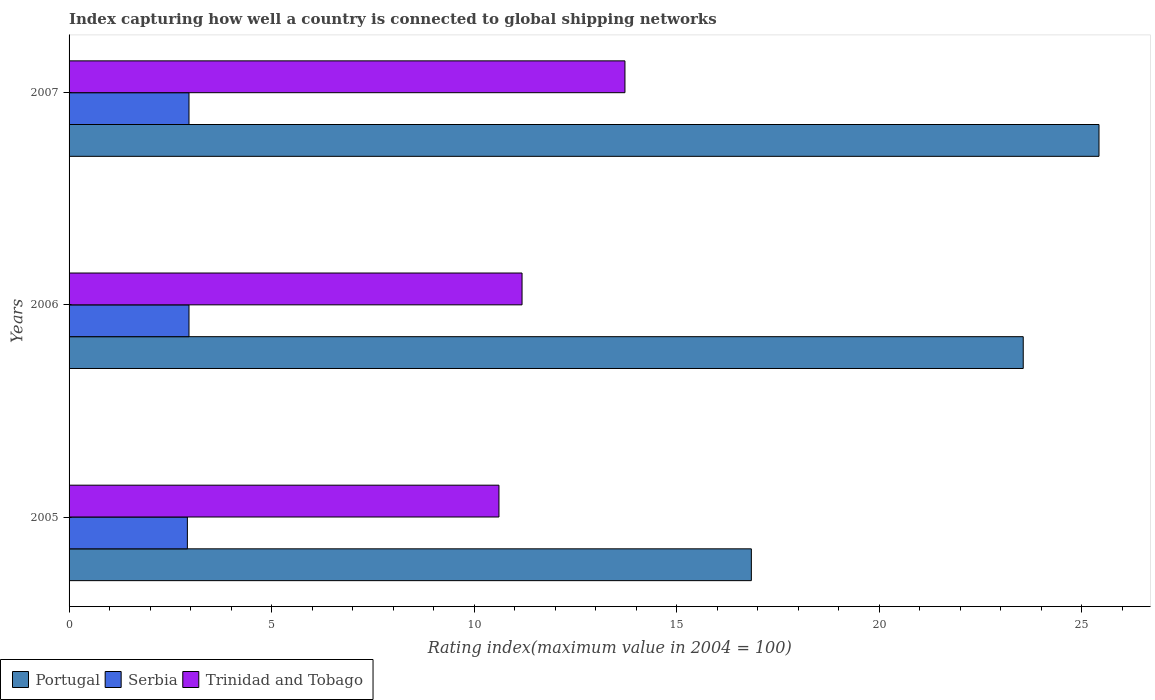How many different coloured bars are there?
Provide a succinct answer. 3. How many groups of bars are there?
Your response must be concise. 3. How many bars are there on the 1st tick from the top?
Provide a short and direct response. 3. How many bars are there on the 2nd tick from the bottom?
Offer a very short reply. 3. In how many cases, is the number of bars for a given year not equal to the number of legend labels?
Offer a very short reply. 0. What is the rating index in Trinidad and Tobago in 2007?
Your response must be concise. 13.72. Across all years, what is the maximum rating index in Serbia?
Your response must be concise. 2.96. Across all years, what is the minimum rating index in Trinidad and Tobago?
Make the answer very short. 10.61. In which year was the rating index in Trinidad and Tobago maximum?
Provide a succinct answer. 2007. What is the total rating index in Portugal in the graph?
Your answer should be very brief. 65.81. What is the difference between the rating index in Portugal in 2005 and that in 2007?
Make the answer very short. -8.58. What is the difference between the rating index in Serbia in 2005 and the rating index in Portugal in 2007?
Ensure brevity in your answer.  -22.5. What is the average rating index in Serbia per year?
Offer a very short reply. 2.95. In the year 2007, what is the difference between the rating index in Serbia and rating index in Portugal?
Give a very brief answer. -22.46. In how many years, is the rating index in Serbia greater than 5 ?
Offer a very short reply. 0. What is the ratio of the rating index in Serbia in 2005 to that in 2006?
Provide a succinct answer. 0.99. What is the difference between the highest and the second highest rating index in Trinidad and Tobago?
Your answer should be compact. 2.54. What is the difference between the highest and the lowest rating index in Serbia?
Offer a very short reply. 0.04. Is the sum of the rating index in Trinidad and Tobago in 2006 and 2007 greater than the maximum rating index in Portugal across all years?
Ensure brevity in your answer.  No. What does the 1st bar from the top in 2007 represents?
Make the answer very short. Trinidad and Tobago. What does the 1st bar from the bottom in 2007 represents?
Provide a short and direct response. Portugal. How many bars are there?
Provide a short and direct response. 9. Are all the bars in the graph horizontal?
Ensure brevity in your answer.  Yes. How many years are there in the graph?
Ensure brevity in your answer.  3. What is the difference between two consecutive major ticks on the X-axis?
Make the answer very short. 5. Are the values on the major ticks of X-axis written in scientific E-notation?
Provide a succinct answer. No. Does the graph contain any zero values?
Your answer should be compact. No. How are the legend labels stacked?
Provide a short and direct response. Horizontal. What is the title of the graph?
Your answer should be very brief. Index capturing how well a country is connected to global shipping networks. What is the label or title of the X-axis?
Provide a succinct answer. Rating index(maximum value in 2004 = 100). What is the label or title of the Y-axis?
Give a very brief answer. Years. What is the Rating index(maximum value in 2004 = 100) of Portugal in 2005?
Provide a succinct answer. 16.84. What is the Rating index(maximum value in 2004 = 100) in Serbia in 2005?
Your response must be concise. 2.92. What is the Rating index(maximum value in 2004 = 100) of Trinidad and Tobago in 2005?
Provide a short and direct response. 10.61. What is the Rating index(maximum value in 2004 = 100) of Portugal in 2006?
Make the answer very short. 23.55. What is the Rating index(maximum value in 2004 = 100) of Serbia in 2006?
Offer a terse response. 2.96. What is the Rating index(maximum value in 2004 = 100) of Trinidad and Tobago in 2006?
Offer a terse response. 11.18. What is the Rating index(maximum value in 2004 = 100) of Portugal in 2007?
Your answer should be very brief. 25.42. What is the Rating index(maximum value in 2004 = 100) in Serbia in 2007?
Keep it short and to the point. 2.96. What is the Rating index(maximum value in 2004 = 100) of Trinidad and Tobago in 2007?
Provide a short and direct response. 13.72. Across all years, what is the maximum Rating index(maximum value in 2004 = 100) of Portugal?
Provide a short and direct response. 25.42. Across all years, what is the maximum Rating index(maximum value in 2004 = 100) of Serbia?
Provide a short and direct response. 2.96. Across all years, what is the maximum Rating index(maximum value in 2004 = 100) of Trinidad and Tobago?
Ensure brevity in your answer.  13.72. Across all years, what is the minimum Rating index(maximum value in 2004 = 100) of Portugal?
Give a very brief answer. 16.84. Across all years, what is the minimum Rating index(maximum value in 2004 = 100) in Serbia?
Give a very brief answer. 2.92. Across all years, what is the minimum Rating index(maximum value in 2004 = 100) of Trinidad and Tobago?
Offer a terse response. 10.61. What is the total Rating index(maximum value in 2004 = 100) in Portugal in the graph?
Offer a very short reply. 65.81. What is the total Rating index(maximum value in 2004 = 100) of Serbia in the graph?
Make the answer very short. 8.84. What is the total Rating index(maximum value in 2004 = 100) of Trinidad and Tobago in the graph?
Offer a very short reply. 35.51. What is the difference between the Rating index(maximum value in 2004 = 100) in Portugal in 2005 and that in 2006?
Your answer should be very brief. -6.71. What is the difference between the Rating index(maximum value in 2004 = 100) in Serbia in 2005 and that in 2006?
Ensure brevity in your answer.  -0.04. What is the difference between the Rating index(maximum value in 2004 = 100) in Trinidad and Tobago in 2005 and that in 2006?
Keep it short and to the point. -0.57. What is the difference between the Rating index(maximum value in 2004 = 100) in Portugal in 2005 and that in 2007?
Keep it short and to the point. -8.58. What is the difference between the Rating index(maximum value in 2004 = 100) in Serbia in 2005 and that in 2007?
Your answer should be compact. -0.04. What is the difference between the Rating index(maximum value in 2004 = 100) in Trinidad and Tobago in 2005 and that in 2007?
Offer a very short reply. -3.11. What is the difference between the Rating index(maximum value in 2004 = 100) of Portugal in 2006 and that in 2007?
Provide a short and direct response. -1.87. What is the difference between the Rating index(maximum value in 2004 = 100) in Serbia in 2006 and that in 2007?
Your answer should be compact. 0. What is the difference between the Rating index(maximum value in 2004 = 100) in Trinidad and Tobago in 2006 and that in 2007?
Offer a terse response. -2.54. What is the difference between the Rating index(maximum value in 2004 = 100) in Portugal in 2005 and the Rating index(maximum value in 2004 = 100) in Serbia in 2006?
Your answer should be compact. 13.88. What is the difference between the Rating index(maximum value in 2004 = 100) of Portugal in 2005 and the Rating index(maximum value in 2004 = 100) of Trinidad and Tobago in 2006?
Give a very brief answer. 5.66. What is the difference between the Rating index(maximum value in 2004 = 100) in Serbia in 2005 and the Rating index(maximum value in 2004 = 100) in Trinidad and Tobago in 2006?
Offer a terse response. -8.26. What is the difference between the Rating index(maximum value in 2004 = 100) of Portugal in 2005 and the Rating index(maximum value in 2004 = 100) of Serbia in 2007?
Your answer should be compact. 13.88. What is the difference between the Rating index(maximum value in 2004 = 100) in Portugal in 2005 and the Rating index(maximum value in 2004 = 100) in Trinidad and Tobago in 2007?
Offer a very short reply. 3.12. What is the difference between the Rating index(maximum value in 2004 = 100) of Portugal in 2006 and the Rating index(maximum value in 2004 = 100) of Serbia in 2007?
Make the answer very short. 20.59. What is the difference between the Rating index(maximum value in 2004 = 100) in Portugal in 2006 and the Rating index(maximum value in 2004 = 100) in Trinidad and Tobago in 2007?
Offer a terse response. 9.83. What is the difference between the Rating index(maximum value in 2004 = 100) of Serbia in 2006 and the Rating index(maximum value in 2004 = 100) of Trinidad and Tobago in 2007?
Ensure brevity in your answer.  -10.76. What is the average Rating index(maximum value in 2004 = 100) in Portugal per year?
Provide a succinct answer. 21.94. What is the average Rating index(maximum value in 2004 = 100) of Serbia per year?
Give a very brief answer. 2.95. What is the average Rating index(maximum value in 2004 = 100) of Trinidad and Tobago per year?
Make the answer very short. 11.84. In the year 2005, what is the difference between the Rating index(maximum value in 2004 = 100) of Portugal and Rating index(maximum value in 2004 = 100) of Serbia?
Your answer should be very brief. 13.92. In the year 2005, what is the difference between the Rating index(maximum value in 2004 = 100) in Portugal and Rating index(maximum value in 2004 = 100) in Trinidad and Tobago?
Give a very brief answer. 6.23. In the year 2005, what is the difference between the Rating index(maximum value in 2004 = 100) of Serbia and Rating index(maximum value in 2004 = 100) of Trinidad and Tobago?
Offer a terse response. -7.69. In the year 2006, what is the difference between the Rating index(maximum value in 2004 = 100) in Portugal and Rating index(maximum value in 2004 = 100) in Serbia?
Offer a very short reply. 20.59. In the year 2006, what is the difference between the Rating index(maximum value in 2004 = 100) in Portugal and Rating index(maximum value in 2004 = 100) in Trinidad and Tobago?
Keep it short and to the point. 12.37. In the year 2006, what is the difference between the Rating index(maximum value in 2004 = 100) of Serbia and Rating index(maximum value in 2004 = 100) of Trinidad and Tobago?
Your response must be concise. -8.22. In the year 2007, what is the difference between the Rating index(maximum value in 2004 = 100) in Portugal and Rating index(maximum value in 2004 = 100) in Serbia?
Provide a short and direct response. 22.46. In the year 2007, what is the difference between the Rating index(maximum value in 2004 = 100) of Portugal and Rating index(maximum value in 2004 = 100) of Trinidad and Tobago?
Provide a short and direct response. 11.7. In the year 2007, what is the difference between the Rating index(maximum value in 2004 = 100) in Serbia and Rating index(maximum value in 2004 = 100) in Trinidad and Tobago?
Your answer should be compact. -10.76. What is the ratio of the Rating index(maximum value in 2004 = 100) of Portugal in 2005 to that in 2006?
Offer a very short reply. 0.72. What is the ratio of the Rating index(maximum value in 2004 = 100) in Serbia in 2005 to that in 2006?
Keep it short and to the point. 0.99. What is the ratio of the Rating index(maximum value in 2004 = 100) in Trinidad and Tobago in 2005 to that in 2006?
Offer a terse response. 0.95. What is the ratio of the Rating index(maximum value in 2004 = 100) of Portugal in 2005 to that in 2007?
Make the answer very short. 0.66. What is the ratio of the Rating index(maximum value in 2004 = 100) of Serbia in 2005 to that in 2007?
Ensure brevity in your answer.  0.99. What is the ratio of the Rating index(maximum value in 2004 = 100) of Trinidad and Tobago in 2005 to that in 2007?
Your answer should be compact. 0.77. What is the ratio of the Rating index(maximum value in 2004 = 100) in Portugal in 2006 to that in 2007?
Your answer should be very brief. 0.93. What is the ratio of the Rating index(maximum value in 2004 = 100) of Serbia in 2006 to that in 2007?
Your response must be concise. 1. What is the ratio of the Rating index(maximum value in 2004 = 100) in Trinidad and Tobago in 2006 to that in 2007?
Your answer should be very brief. 0.81. What is the difference between the highest and the second highest Rating index(maximum value in 2004 = 100) of Portugal?
Provide a succinct answer. 1.87. What is the difference between the highest and the second highest Rating index(maximum value in 2004 = 100) of Trinidad and Tobago?
Your answer should be very brief. 2.54. What is the difference between the highest and the lowest Rating index(maximum value in 2004 = 100) in Portugal?
Your answer should be very brief. 8.58. What is the difference between the highest and the lowest Rating index(maximum value in 2004 = 100) of Trinidad and Tobago?
Your answer should be very brief. 3.11. 